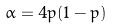Convert formula to latex. <formula><loc_0><loc_0><loc_500><loc_500>\alpha = 4 p ( 1 - p )</formula> 